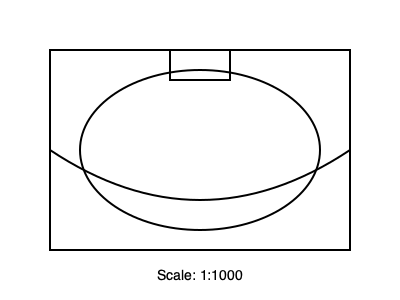Based on the architectural floor plan shown, which famous concert hall is this likely to represent? To identify this concert hall, let's analyze the key features of the floor plan:

1. The overall shape is rectangular with curved elements.
2. There's a large elliptical area in the center, likely representing the main auditorium.
3. A small rectangular protrusion is visible at the top, possibly indicating the stage area.
4. The bottom of the plan shows a curved line, suggesting a unique architectural feature.

These characteristics are distinctive of the Royal Albert Hall in London, UK:

1. The rectangular outer shape matches the building's exterior.
2. The elliptical center is the hall's famous arena and surrounding seating areas.
3. The small rectangle at the top represents the stage.
4. The curved bottom line indicates the hall's iconic mushroom-shaped acoustic diffusers (often called "mushrooms" or "flying saucers").

The Royal Albert Hall is known for its unique circular design within a rectangular frame, which this floor plan clearly depicts. As an internationally renowned violin soloist, you would likely be familiar with this iconic venue, having potentially performed there or aspired to do so.
Answer: Royal Albert Hall 